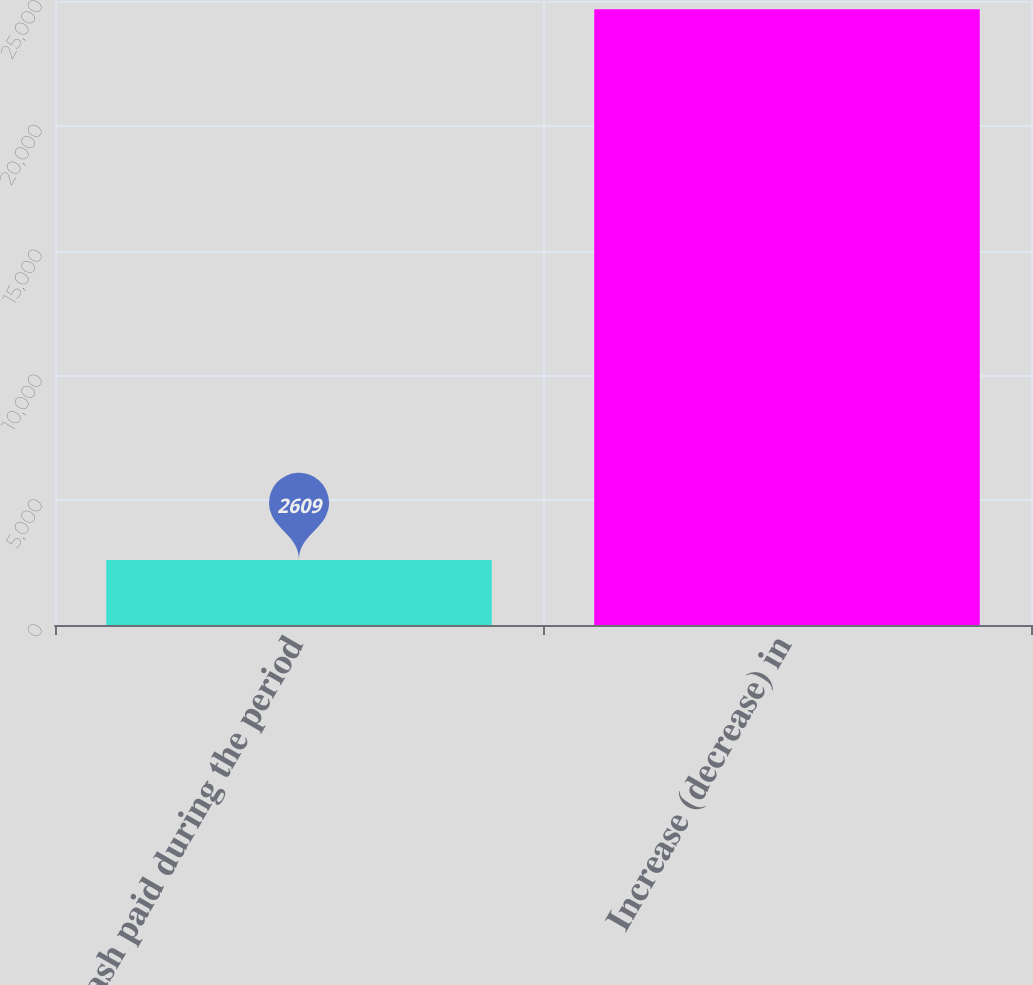Convert chart. <chart><loc_0><loc_0><loc_500><loc_500><bar_chart><fcel>Cash paid during the period<fcel>Increase (decrease) in<nl><fcel>2609<fcel>24674.4<nl></chart> 